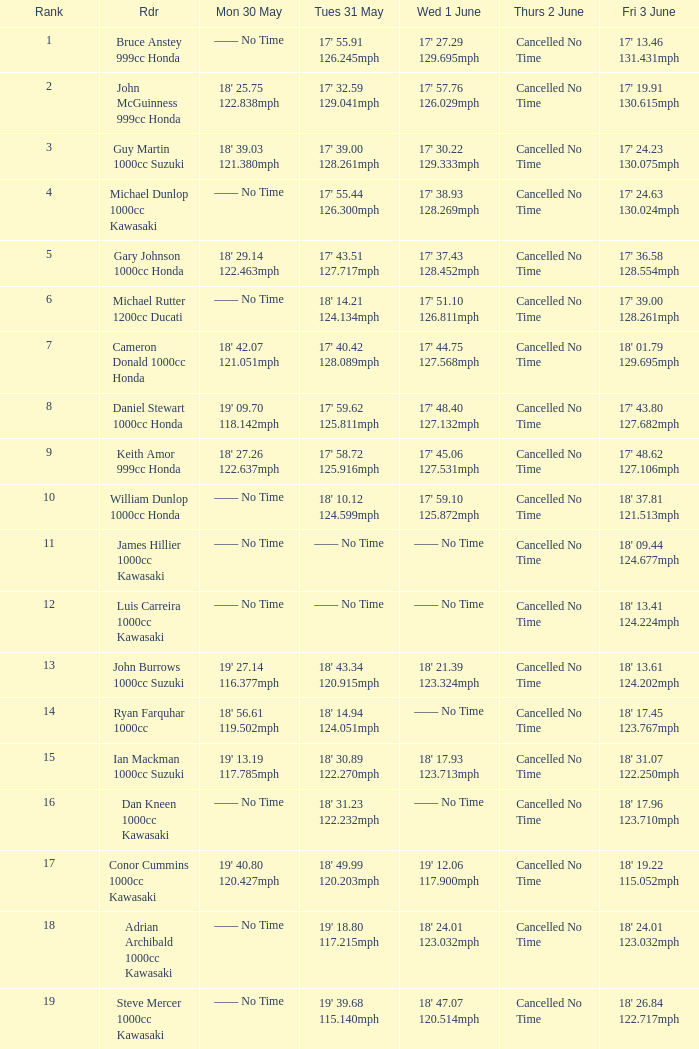What is the Fri 3 June time for the rider whose Tues 31 May time was 19' 18.80 117.215mph? 18' 24.01 123.032mph. 